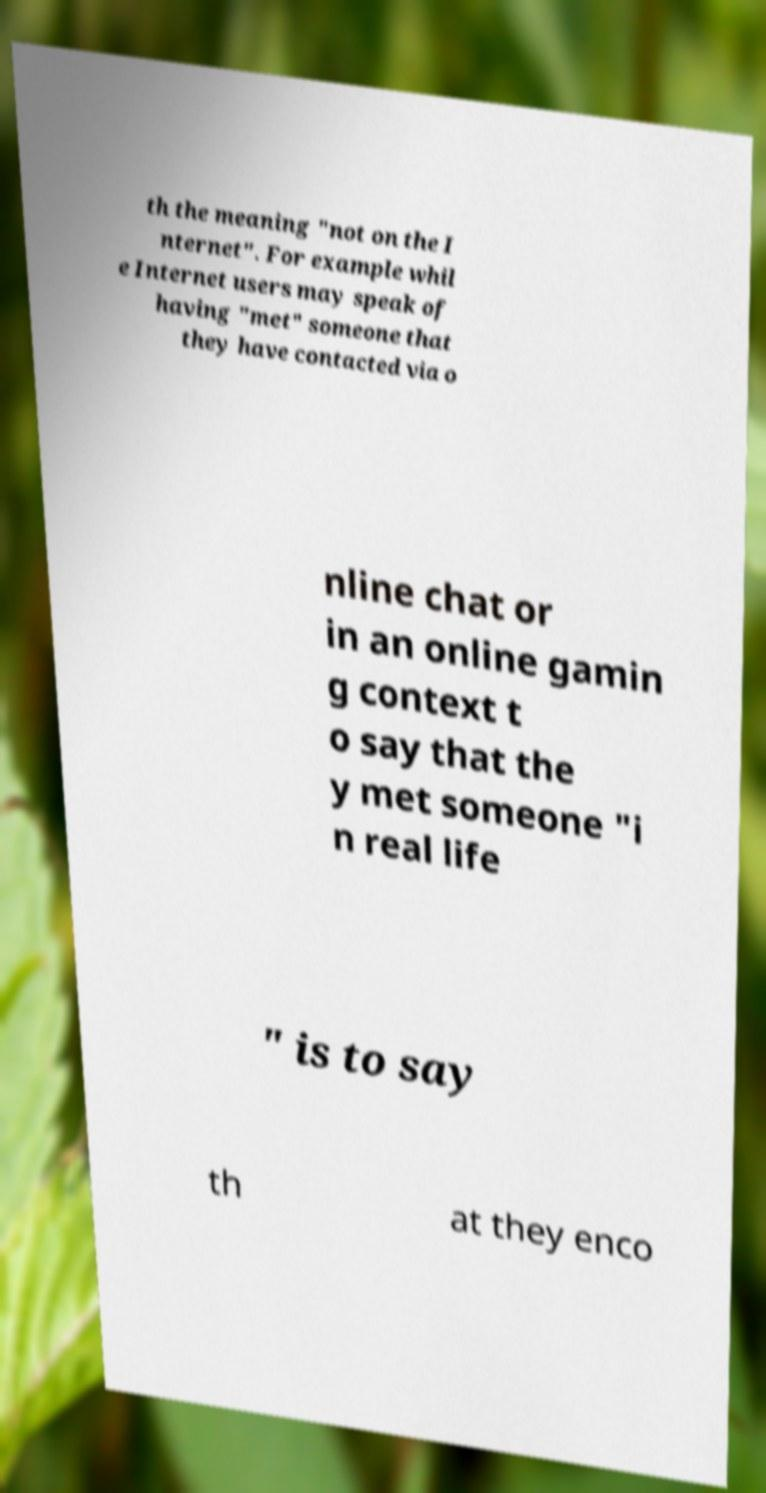What messages or text are displayed in this image? I need them in a readable, typed format. th the meaning "not on the I nternet". For example whil e Internet users may speak of having "met" someone that they have contacted via o nline chat or in an online gamin g context t o say that the y met someone "i n real life " is to say th at they enco 